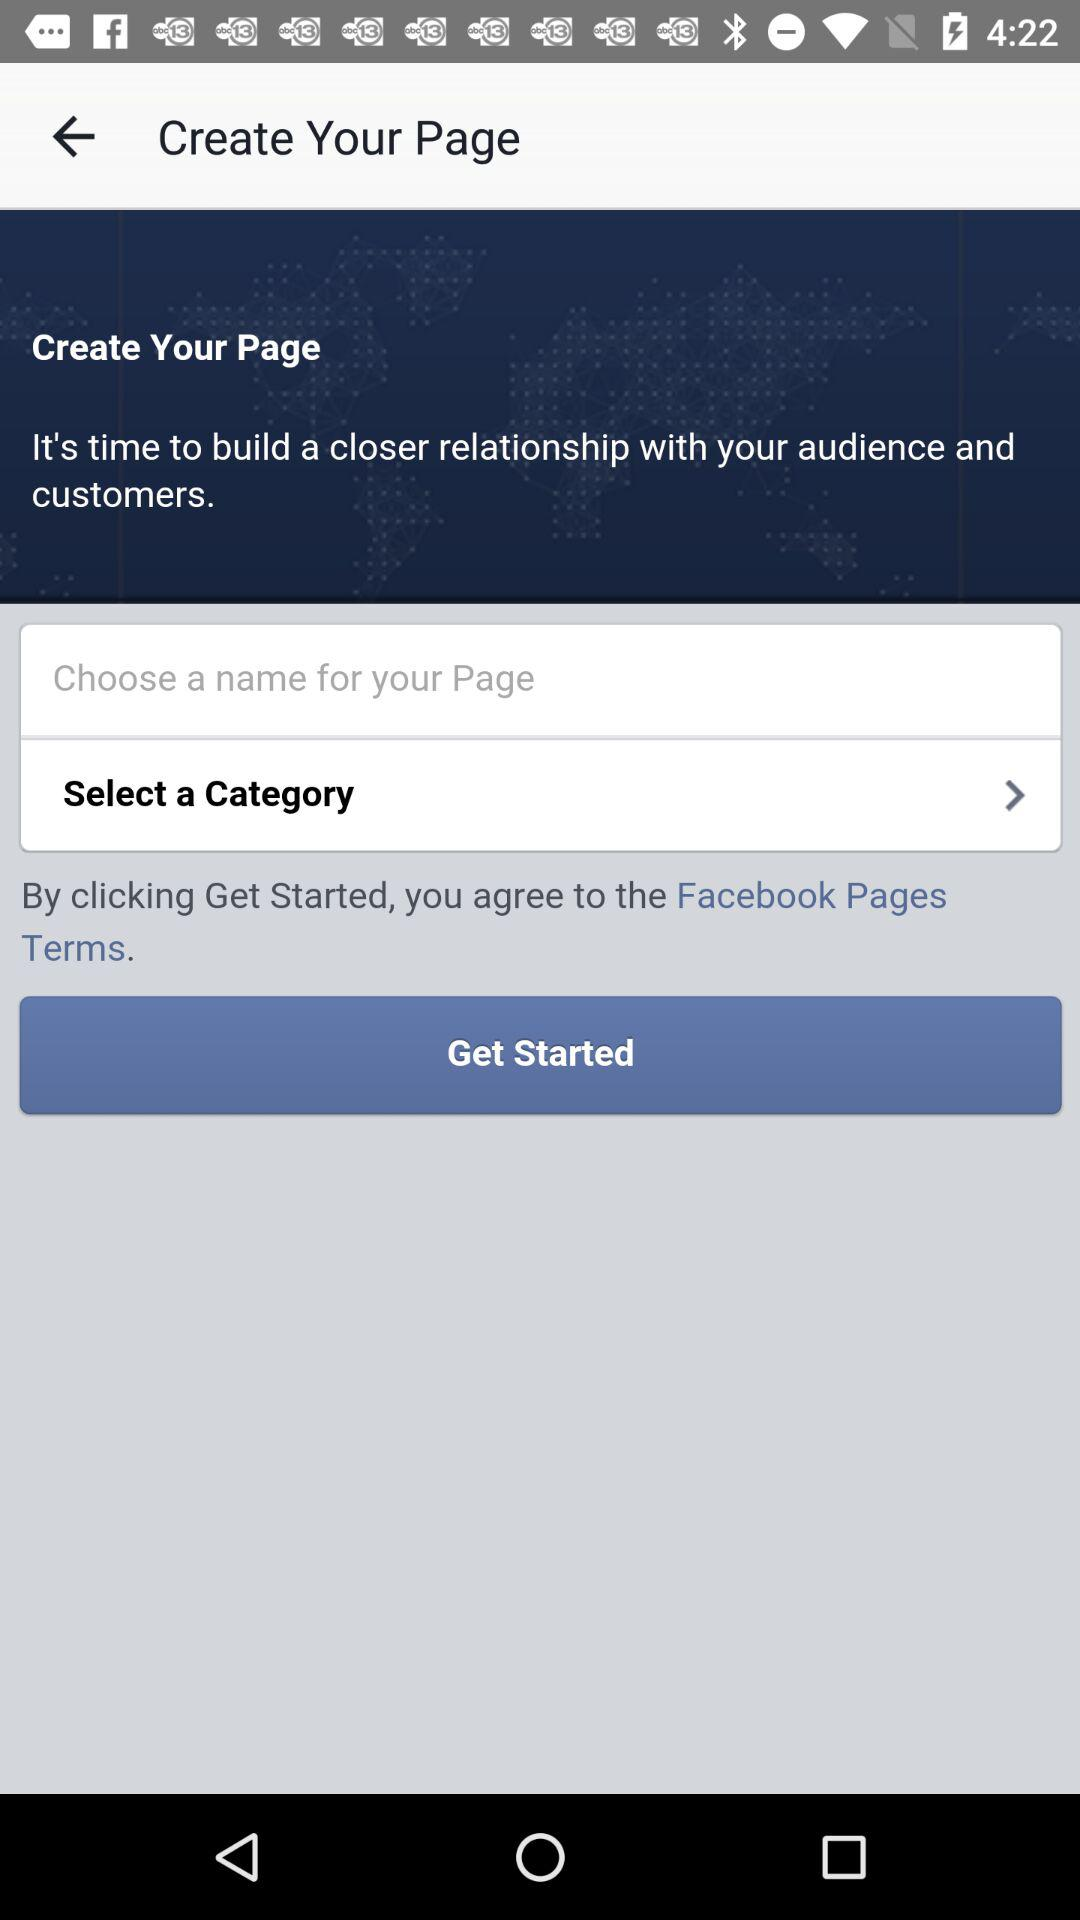How many more steps are there after selecting a category than after choosing a name?
Answer the question using a single word or phrase. 1 